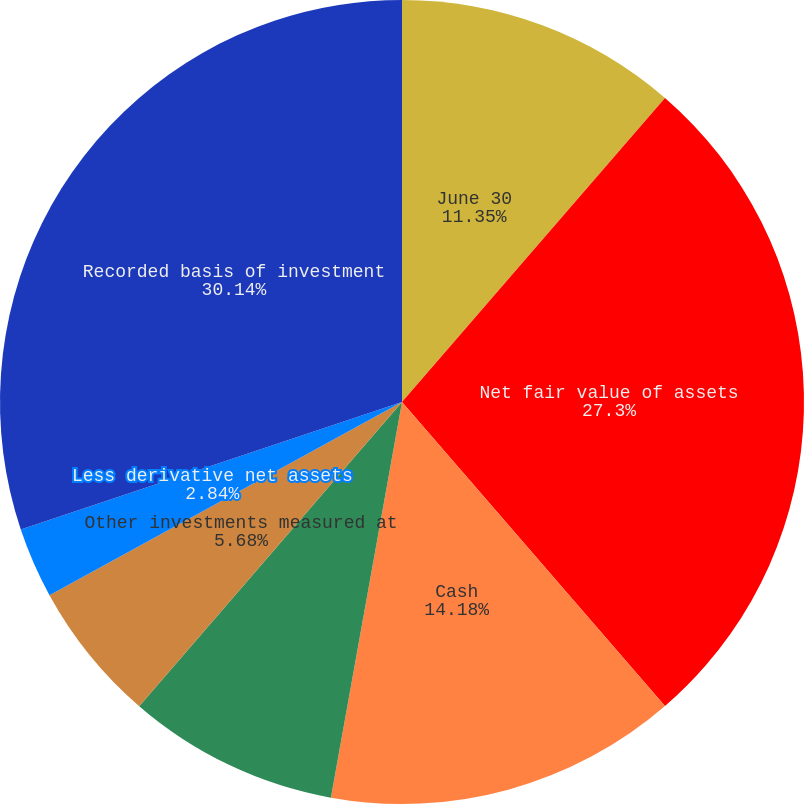Convert chart to OTSL. <chart><loc_0><loc_0><loc_500><loc_500><pie_chart><fcel>June 30<fcel>Net fair value of assets<fcel>Cash<fcel>Common and preferred stock<fcel>Other investments measured at<fcel>Less derivative net assets<fcel>Other<fcel>Recorded basis of investment<nl><fcel>11.35%<fcel>27.3%<fcel>14.18%<fcel>8.51%<fcel>5.68%<fcel>2.84%<fcel>0.0%<fcel>30.14%<nl></chart> 